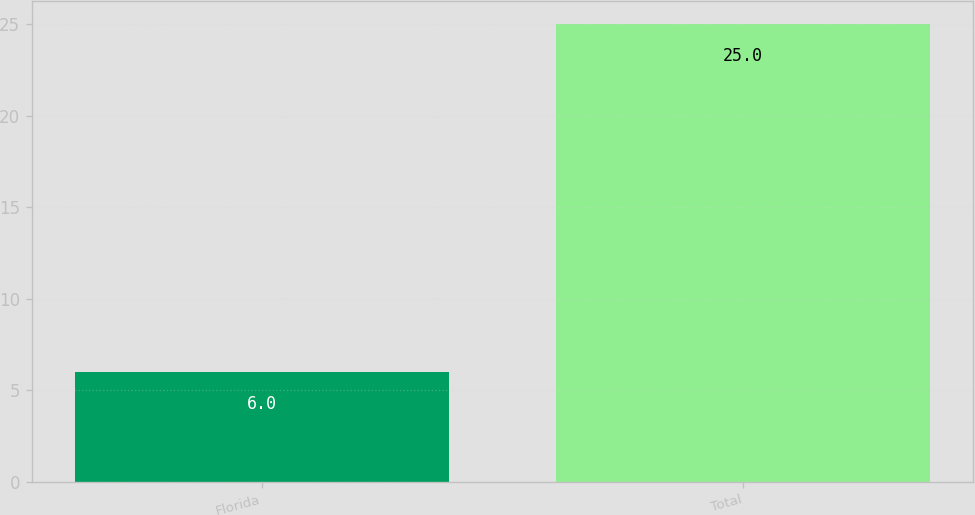Convert chart. <chart><loc_0><loc_0><loc_500><loc_500><bar_chart><fcel>Florida<fcel>Total<nl><fcel>6<fcel>25<nl></chart> 